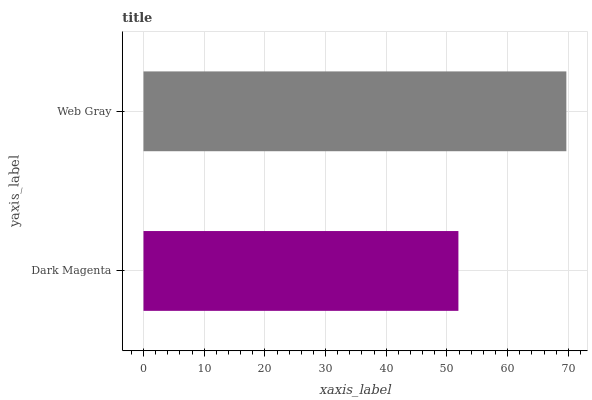Is Dark Magenta the minimum?
Answer yes or no. Yes. Is Web Gray the maximum?
Answer yes or no. Yes. Is Web Gray the minimum?
Answer yes or no. No. Is Web Gray greater than Dark Magenta?
Answer yes or no. Yes. Is Dark Magenta less than Web Gray?
Answer yes or no. Yes. Is Dark Magenta greater than Web Gray?
Answer yes or no. No. Is Web Gray less than Dark Magenta?
Answer yes or no. No. Is Web Gray the high median?
Answer yes or no. Yes. Is Dark Magenta the low median?
Answer yes or no. Yes. Is Dark Magenta the high median?
Answer yes or no. No. Is Web Gray the low median?
Answer yes or no. No. 